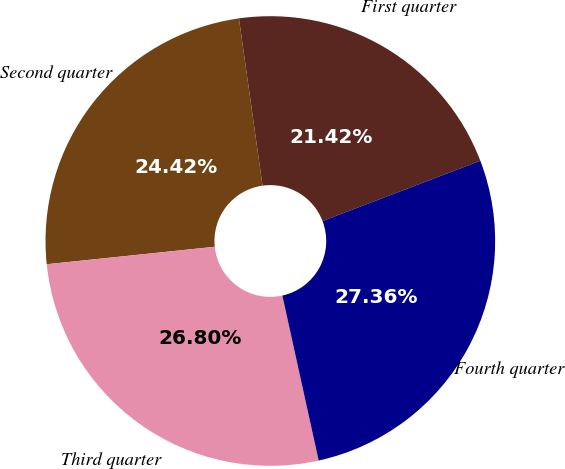<chart> <loc_0><loc_0><loc_500><loc_500><pie_chart><fcel>First quarter<fcel>Second quarter<fcel>Third quarter<fcel>Fourth quarter<nl><fcel>21.42%<fcel>24.42%<fcel>26.8%<fcel>27.36%<nl></chart> 